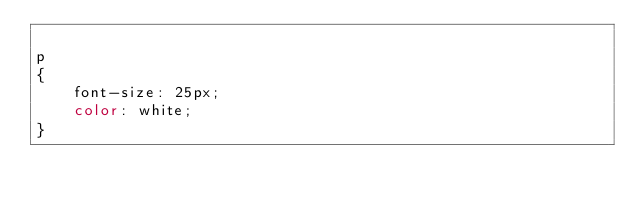<code> <loc_0><loc_0><loc_500><loc_500><_CSS_>
p
{
    font-size: 25px;
    color: white;
}

</code> 